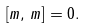Convert formula to latex. <formula><loc_0><loc_0><loc_500><loc_500>\left [ m , \, m \right ] = 0 .</formula> 